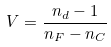<formula> <loc_0><loc_0><loc_500><loc_500>V = \frac { n _ { d } - 1 } { n _ { F } - n _ { C } }</formula> 